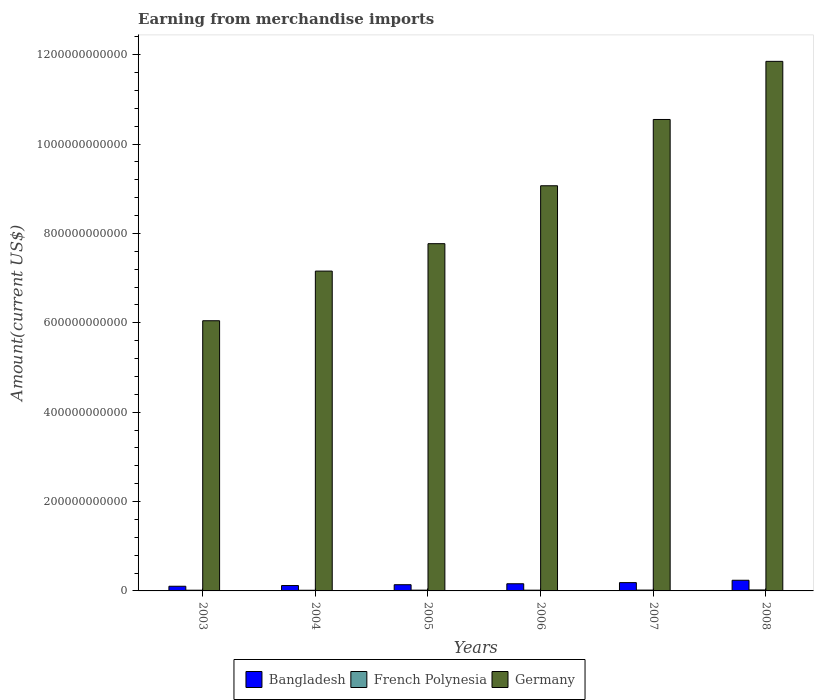How many bars are there on the 6th tick from the left?
Give a very brief answer. 3. What is the amount earned from merchandise imports in Bangladesh in 2006?
Offer a very short reply. 1.60e+1. Across all years, what is the maximum amount earned from merchandise imports in French Polynesia?
Ensure brevity in your answer.  2.17e+09. Across all years, what is the minimum amount earned from merchandise imports in Germany?
Provide a short and direct response. 6.05e+11. In which year was the amount earned from merchandise imports in Bangladesh maximum?
Ensure brevity in your answer.  2008. What is the total amount earned from merchandise imports in French Polynesia in the graph?
Make the answer very short. 1.05e+1. What is the difference between the amount earned from merchandise imports in Germany in 2005 and that in 2006?
Your response must be concise. -1.30e+11. What is the difference between the amount earned from merchandise imports in French Polynesia in 2007 and the amount earned from merchandise imports in Germany in 2005?
Offer a terse response. -7.75e+11. What is the average amount earned from merchandise imports in French Polynesia per year?
Offer a terse response. 1.75e+09. In the year 2005, what is the difference between the amount earned from merchandise imports in Bangladesh and amount earned from merchandise imports in French Polynesia?
Give a very brief answer. 1.22e+1. In how many years, is the amount earned from merchandise imports in French Polynesia greater than 480000000000 US$?
Ensure brevity in your answer.  0. What is the ratio of the amount earned from merchandise imports in French Polynesia in 2006 to that in 2008?
Offer a terse response. 0.76. Is the difference between the amount earned from merchandise imports in Bangladesh in 2005 and 2007 greater than the difference between the amount earned from merchandise imports in French Polynesia in 2005 and 2007?
Provide a short and direct response. No. What is the difference between the highest and the second highest amount earned from merchandise imports in Bangladesh?
Ensure brevity in your answer.  5.26e+09. What is the difference between the highest and the lowest amount earned from merchandise imports in French Polynesia?
Your response must be concise. 6.69e+08. In how many years, is the amount earned from merchandise imports in Bangladesh greater than the average amount earned from merchandise imports in Bangladesh taken over all years?
Offer a terse response. 3. How many bars are there?
Provide a succinct answer. 18. Are all the bars in the graph horizontal?
Your response must be concise. No. How many years are there in the graph?
Provide a short and direct response. 6. What is the difference between two consecutive major ticks on the Y-axis?
Your answer should be very brief. 2.00e+11. Does the graph contain any zero values?
Keep it short and to the point. No. Where does the legend appear in the graph?
Your response must be concise. Bottom center. How many legend labels are there?
Give a very brief answer. 3. How are the legend labels stacked?
Keep it short and to the point. Horizontal. What is the title of the graph?
Your answer should be very brief. Earning from merchandise imports. What is the label or title of the Y-axis?
Your answer should be compact. Amount(current US$). What is the Amount(current US$) of Bangladesh in 2003?
Provide a succinct answer. 1.04e+1. What is the Amount(current US$) of French Polynesia in 2003?
Provide a short and direct response. 1.58e+09. What is the Amount(current US$) in Germany in 2003?
Make the answer very short. 6.05e+11. What is the Amount(current US$) of Bangladesh in 2004?
Offer a very short reply. 1.20e+1. What is the Amount(current US$) in French Polynesia in 2004?
Your answer should be compact. 1.50e+09. What is the Amount(current US$) in Germany in 2004?
Give a very brief answer. 7.16e+11. What is the Amount(current US$) in Bangladesh in 2005?
Your answer should be compact. 1.39e+1. What is the Amount(current US$) of French Polynesia in 2005?
Your response must be concise. 1.72e+09. What is the Amount(current US$) in Germany in 2005?
Your answer should be very brief. 7.77e+11. What is the Amount(current US$) in Bangladesh in 2006?
Provide a succinct answer. 1.60e+1. What is the Amount(current US$) in French Polynesia in 2006?
Your response must be concise. 1.66e+09. What is the Amount(current US$) of Germany in 2006?
Keep it short and to the point. 9.07e+11. What is the Amount(current US$) of Bangladesh in 2007?
Your answer should be compact. 1.86e+1. What is the Amount(current US$) in French Polynesia in 2007?
Your answer should be compact. 1.86e+09. What is the Amount(current US$) of Germany in 2007?
Provide a short and direct response. 1.05e+12. What is the Amount(current US$) in Bangladesh in 2008?
Your answer should be very brief. 2.39e+1. What is the Amount(current US$) in French Polynesia in 2008?
Give a very brief answer. 2.17e+09. What is the Amount(current US$) of Germany in 2008?
Make the answer very short. 1.19e+12. Across all years, what is the maximum Amount(current US$) in Bangladesh?
Keep it short and to the point. 2.39e+1. Across all years, what is the maximum Amount(current US$) in French Polynesia?
Your answer should be compact. 2.17e+09. Across all years, what is the maximum Amount(current US$) in Germany?
Provide a succinct answer. 1.19e+12. Across all years, what is the minimum Amount(current US$) in Bangladesh?
Give a very brief answer. 1.04e+1. Across all years, what is the minimum Amount(current US$) of French Polynesia?
Make the answer very short. 1.50e+09. Across all years, what is the minimum Amount(current US$) in Germany?
Offer a terse response. 6.05e+11. What is the total Amount(current US$) of Bangladesh in the graph?
Provide a short and direct response. 9.48e+1. What is the total Amount(current US$) in French Polynesia in the graph?
Offer a terse response. 1.05e+1. What is the total Amount(current US$) in Germany in the graph?
Your response must be concise. 5.24e+12. What is the difference between the Amount(current US$) in Bangladesh in 2003 and that in 2004?
Ensure brevity in your answer.  -1.60e+09. What is the difference between the Amount(current US$) in French Polynesia in 2003 and that in 2004?
Offer a terse response. 8.51e+07. What is the difference between the Amount(current US$) of Germany in 2003 and that in 2004?
Make the answer very short. -1.11e+11. What is the difference between the Amount(current US$) of Bangladesh in 2003 and that in 2005?
Keep it short and to the point. -3.46e+09. What is the difference between the Amount(current US$) in French Polynesia in 2003 and that in 2005?
Give a very brief answer. -1.38e+08. What is the difference between the Amount(current US$) in Germany in 2003 and that in 2005?
Offer a terse response. -1.72e+11. What is the difference between the Amount(current US$) of Bangladesh in 2003 and that in 2006?
Your answer should be compact. -5.60e+09. What is the difference between the Amount(current US$) of French Polynesia in 2003 and that in 2006?
Your answer should be very brief. -7.06e+07. What is the difference between the Amount(current US$) of Germany in 2003 and that in 2006?
Provide a succinct answer. -3.02e+11. What is the difference between the Amount(current US$) in Bangladesh in 2003 and that in 2007?
Offer a terse response. -8.16e+09. What is the difference between the Amount(current US$) of French Polynesia in 2003 and that in 2007?
Your response must be concise. -2.78e+08. What is the difference between the Amount(current US$) in Germany in 2003 and that in 2007?
Provide a succinct answer. -4.50e+11. What is the difference between the Amount(current US$) in Bangladesh in 2003 and that in 2008?
Provide a succinct answer. -1.34e+1. What is the difference between the Amount(current US$) in French Polynesia in 2003 and that in 2008?
Ensure brevity in your answer.  -5.84e+08. What is the difference between the Amount(current US$) in Germany in 2003 and that in 2008?
Your response must be concise. -5.80e+11. What is the difference between the Amount(current US$) of Bangladesh in 2004 and that in 2005?
Offer a very short reply. -1.85e+09. What is the difference between the Amount(current US$) of French Polynesia in 2004 and that in 2005?
Ensure brevity in your answer.  -2.23e+08. What is the difference between the Amount(current US$) of Germany in 2004 and that in 2005?
Provide a succinct answer. -6.13e+1. What is the difference between the Amount(current US$) of Bangladesh in 2004 and that in 2006?
Your answer should be very brief. -4.00e+09. What is the difference between the Amount(current US$) in French Polynesia in 2004 and that in 2006?
Ensure brevity in your answer.  -1.56e+08. What is the difference between the Amount(current US$) of Germany in 2004 and that in 2006?
Make the answer very short. -1.91e+11. What is the difference between the Amount(current US$) of Bangladesh in 2004 and that in 2007?
Make the answer very short. -6.56e+09. What is the difference between the Amount(current US$) in French Polynesia in 2004 and that in 2007?
Your answer should be compact. -3.63e+08. What is the difference between the Amount(current US$) of Germany in 2004 and that in 2007?
Provide a succinct answer. -3.39e+11. What is the difference between the Amount(current US$) in Bangladesh in 2004 and that in 2008?
Keep it short and to the point. -1.18e+1. What is the difference between the Amount(current US$) in French Polynesia in 2004 and that in 2008?
Your response must be concise. -6.69e+08. What is the difference between the Amount(current US$) in Germany in 2004 and that in 2008?
Provide a short and direct response. -4.69e+11. What is the difference between the Amount(current US$) of Bangladesh in 2005 and that in 2006?
Provide a succinct answer. -2.14e+09. What is the difference between the Amount(current US$) in French Polynesia in 2005 and that in 2006?
Keep it short and to the point. 6.76e+07. What is the difference between the Amount(current US$) of Germany in 2005 and that in 2006?
Provide a succinct answer. -1.30e+11. What is the difference between the Amount(current US$) of Bangladesh in 2005 and that in 2007?
Provide a short and direct response. -4.71e+09. What is the difference between the Amount(current US$) in French Polynesia in 2005 and that in 2007?
Ensure brevity in your answer.  -1.40e+08. What is the difference between the Amount(current US$) of Germany in 2005 and that in 2007?
Make the answer very short. -2.78e+11. What is the difference between the Amount(current US$) of Bangladesh in 2005 and that in 2008?
Offer a very short reply. -9.97e+09. What is the difference between the Amount(current US$) in French Polynesia in 2005 and that in 2008?
Give a very brief answer. -4.45e+08. What is the difference between the Amount(current US$) of Germany in 2005 and that in 2008?
Offer a very short reply. -4.08e+11. What is the difference between the Amount(current US$) of Bangladesh in 2006 and that in 2007?
Your answer should be compact. -2.56e+09. What is the difference between the Amount(current US$) of French Polynesia in 2006 and that in 2007?
Offer a terse response. -2.08e+08. What is the difference between the Amount(current US$) of Germany in 2006 and that in 2007?
Offer a terse response. -1.48e+11. What is the difference between the Amount(current US$) in Bangladesh in 2006 and that in 2008?
Your answer should be very brief. -7.83e+09. What is the difference between the Amount(current US$) in French Polynesia in 2006 and that in 2008?
Your answer should be very brief. -5.13e+08. What is the difference between the Amount(current US$) in Germany in 2006 and that in 2008?
Provide a short and direct response. -2.78e+11. What is the difference between the Amount(current US$) of Bangladesh in 2007 and that in 2008?
Provide a succinct answer. -5.26e+09. What is the difference between the Amount(current US$) of French Polynesia in 2007 and that in 2008?
Give a very brief answer. -3.06e+08. What is the difference between the Amount(current US$) in Germany in 2007 and that in 2008?
Your response must be concise. -1.30e+11. What is the difference between the Amount(current US$) in Bangladesh in 2003 and the Amount(current US$) in French Polynesia in 2004?
Make the answer very short. 8.93e+09. What is the difference between the Amount(current US$) of Bangladesh in 2003 and the Amount(current US$) of Germany in 2004?
Provide a succinct answer. -7.05e+11. What is the difference between the Amount(current US$) in French Polynesia in 2003 and the Amount(current US$) in Germany in 2004?
Offer a terse response. -7.14e+11. What is the difference between the Amount(current US$) of Bangladesh in 2003 and the Amount(current US$) of French Polynesia in 2005?
Offer a terse response. 8.71e+09. What is the difference between the Amount(current US$) in Bangladesh in 2003 and the Amount(current US$) in Germany in 2005?
Offer a very short reply. -7.67e+11. What is the difference between the Amount(current US$) in French Polynesia in 2003 and the Amount(current US$) in Germany in 2005?
Your response must be concise. -7.75e+11. What is the difference between the Amount(current US$) in Bangladesh in 2003 and the Amount(current US$) in French Polynesia in 2006?
Provide a succinct answer. 8.78e+09. What is the difference between the Amount(current US$) of Bangladesh in 2003 and the Amount(current US$) of Germany in 2006?
Ensure brevity in your answer.  -8.96e+11. What is the difference between the Amount(current US$) in French Polynesia in 2003 and the Amount(current US$) in Germany in 2006?
Ensure brevity in your answer.  -9.05e+11. What is the difference between the Amount(current US$) in Bangladesh in 2003 and the Amount(current US$) in French Polynesia in 2007?
Your answer should be very brief. 8.57e+09. What is the difference between the Amount(current US$) of Bangladesh in 2003 and the Amount(current US$) of Germany in 2007?
Provide a short and direct response. -1.04e+12. What is the difference between the Amount(current US$) in French Polynesia in 2003 and the Amount(current US$) in Germany in 2007?
Provide a succinct answer. -1.05e+12. What is the difference between the Amount(current US$) in Bangladesh in 2003 and the Amount(current US$) in French Polynesia in 2008?
Make the answer very short. 8.27e+09. What is the difference between the Amount(current US$) in Bangladesh in 2003 and the Amount(current US$) in Germany in 2008?
Provide a succinct answer. -1.17e+12. What is the difference between the Amount(current US$) in French Polynesia in 2003 and the Amount(current US$) in Germany in 2008?
Ensure brevity in your answer.  -1.18e+12. What is the difference between the Amount(current US$) of Bangladesh in 2004 and the Amount(current US$) of French Polynesia in 2005?
Give a very brief answer. 1.03e+1. What is the difference between the Amount(current US$) of Bangladesh in 2004 and the Amount(current US$) of Germany in 2005?
Give a very brief answer. -7.65e+11. What is the difference between the Amount(current US$) in French Polynesia in 2004 and the Amount(current US$) in Germany in 2005?
Offer a very short reply. -7.76e+11. What is the difference between the Amount(current US$) of Bangladesh in 2004 and the Amount(current US$) of French Polynesia in 2006?
Give a very brief answer. 1.04e+1. What is the difference between the Amount(current US$) in Bangladesh in 2004 and the Amount(current US$) in Germany in 2006?
Ensure brevity in your answer.  -8.95e+11. What is the difference between the Amount(current US$) in French Polynesia in 2004 and the Amount(current US$) in Germany in 2006?
Make the answer very short. -9.05e+11. What is the difference between the Amount(current US$) in Bangladesh in 2004 and the Amount(current US$) in French Polynesia in 2007?
Your response must be concise. 1.02e+1. What is the difference between the Amount(current US$) in Bangladesh in 2004 and the Amount(current US$) in Germany in 2007?
Offer a terse response. -1.04e+12. What is the difference between the Amount(current US$) of French Polynesia in 2004 and the Amount(current US$) of Germany in 2007?
Ensure brevity in your answer.  -1.05e+12. What is the difference between the Amount(current US$) in Bangladesh in 2004 and the Amount(current US$) in French Polynesia in 2008?
Provide a short and direct response. 9.87e+09. What is the difference between the Amount(current US$) of Bangladesh in 2004 and the Amount(current US$) of Germany in 2008?
Your answer should be very brief. -1.17e+12. What is the difference between the Amount(current US$) of French Polynesia in 2004 and the Amount(current US$) of Germany in 2008?
Make the answer very short. -1.18e+12. What is the difference between the Amount(current US$) of Bangladesh in 2005 and the Amount(current US$) of French Polynesia in 2006?
Make the answer very short. 1.22e+1. What is the difference between the Amount(current US$) of Bangladesh in 2005 and the Amount(current US$) of Germany in 2006?
Provide a succinct answer. -8.93e+11. What is the difference between the Amount(current US$) in French Polynesia in 2005 and the Amount(current US$) in Germany in 2006?
Keep it short and to the point. -9.05e+11. What is the difference between the Amount(current US$) of Bangladesh in 2005 and the Amount(current US$) of French Polynesia in 2007?
Provide a succinct answer. 1.20e+1. What is the difference between the Amount(current US$) in Bangladesh in 2005 and the Amount(current US$) in Germany in 2007?
Make the answer very short. -1.04e+12. What is the difference between the Amount(current US$) in French Polynesia in 2005 and the Amount(current US$) in Germany in 2007?
Your answer should be very brief. -1.05e+12. What is the difference between the Amount(current US$) in Bangladesh in 2005 and the Amount(current US$) in French Polynesia in 2008?
Your response must be concise. 1.17e+1. What is the difference between the Amount(current US$) of Bangladesh in 2005 and the Amount(current US$) of Germany in 2008?
Make the answer very short. -1.17e+12. What is the difference between the Amount(current US$) in French Polynesia in 2005 and the Amount(current US$) in Germany in 2008?
Offer a terse response. -1.18e+12. What is the difference between the Amount(current US$) in Bangladesh in 2006 and the Amount(current US$) in French Polynesia in 2007?
Ensure brevity in your answer.  1.42e+1. What is the difference between the Amount(current US$) in Bangladesh in 2006 and the Amount(current US$) in Germany in 2007?
Offer a terse response. -1.04e+12. What is the difference between the Amount(current US$) of French Polynesia in 2006 and the Amount(current US$) of Germany in 2007?
Provide a succinct answer. -1.05e+12. What is the difference between the Amount(current US$) in Bangladesh in 2006 and the Amount(current US$) in French Polynesia in 2008?
Make the answer very short. 1.39e+1. What is the difference between the Amount(current US$) of Bangladesh in 2006 and the Amount(current US$) of Germany in 2008?
Provide a short and direct response. -1.17e+12. What is the difference between the Amount(current US$) of French Polynesia in 2006 and the Amount(current US$) of Germany in 2008?
Offer a terse response. -1.18e+12. What is the difference between the Amount(current US$) of Bangladesh in 2007 and the Amount(current US$) of French Polynesia in 2008?
Give a very brief answer. 1.64e+1. What is the difference between the Amount(current US$) of Bangladesh in 2007 and the Amount(current US$) of Germany in 2008?
Give a very brief answer. -1.17e+12. What is the difference between the Amount(current US$) of French Polynesia in 2007 and the Amount(current US$) of Germany in 2008?
Make the answer very short. -1.18e+12. What is the average Amount(current US$) of Bangladesh per year?
Your answer should be compact. 1.58e+1. What is the average Amount(current US$) in French Polynesia per year?
Offer a terse response. 1.75e+09. What is the average Amount(current US$) of Germany per year?
Your answer should be compact. 8.74e+11. In the year 2003, what is the difference between the Amount(current US$) of Bangladesh and Amount(current US$) of French Polynesia?
Offer a terse response. 8.85e+09. In the year 2003, what is the difference between the Amount(current US$) in Bangladesh and Amount(current US$) in Germany?
Your response must be concise. -5.94e+11. In the year 2003, what is the difference between the Amount(current US$) in French Polynesia and Amount(current US$) in Germany?
Give a very brief answer. -6.03e+11. In the year 2004, what is the difference between the Amount(current US$) in Bangladesh and Amount(current US$) in French Polynesia?
Your answer should be compact. 1.05e+1. In the year 2004, what is the difference between the Amount(current US$) of Bangladesh and Amount(current US$) of Germany?
Provide a succinct answer. -7.04e+11. In the year 2004, what is the difference between the Amount(current US$) of French Polynesia and Amount(current US$) of Germany?
Offer a terse response. -7.14e+11. In the year 2005, what is the difference between the Amount(current US$) in Bangladesh and Amount(current US$) in French Polynesia?
Offer a very short reply. 1.22e+1. In the year 2005, what is the difference between the Amount(current US$) of Bangladesh and Amount(current US$) of Germany?
Your response must be concise. -7.63e+11. In the year 2005, what is the difference between the Amount(current US$) in French Polynesia and Amount(current US$) in Germany?
Offer a very short reply. -7.75e+11. In the year 2006, what is the difference between the Amount(current US$) of Bangladesh and Amount(current US$) of French Polynesia?
Your answer should be very brief. 1.44e+1. In the year 2006, what is the difference between the Amount(current US$) of Bangladesh and Amount(current US$) of Germany?
Keep it short and to the point. -8.91e+11. In the year 2006, what is the difference between the Amount(current US$) in French Polynesia and Amount(current US$) in Germany?
Offer a terse response. -9.05e+11. In the year 2007, what is the difference between the Amount(current US$) of Bangladesh and Amount(current US$) of French Polynesia?
Give a very brief answer. 1.67e+1. In the year 2007, what is the difference between the Amount(current US$) of Bangladesh and Amount(current US$) of Germany?
Offer a terse response. -1.04e+12. In the year 2007, what is the difference between the Amount(current US$) in French Polynesia and Amount(current US$) in Germany?
Give a very brief answer. -1.05e+12. In the year 2008, what is the difference between the Amount(current US$) in Bangladesh and Amount(current US$) in French Polynesia?
Provide a succinct answer. 2.17e+1. In the year 2008, what is the difference between the Amount(current US$) of Bangladesh and Amount(current US$) of Germany?
Keep it short and to the point. -1.16e+12. In the year 2008, what is the difference between the Amount(current US$) in French Polynesia and Amount(current US$) in Germany?
Make the answer very short. -1.18e+12. What is the ratio of the Amount(current US$) in Bangladesh in 2003 to that in 2004?
Your response must be concise. 0.87. What is the ratio of the Amount(current US$) in French Polynesia in 2003 to that in 2004?
Make the answer very short. 1.06. What is the ratio of the Amount(current US$) in Germany in 2003 to that in 2004?
Offer a terse response. 0.84. What is the ratio of the Amount(current US$) in Bangladesh in 2003 to that in 2005?
Your response must be concise. 0.75. What is the ratio of the Amount(current US$) of French Polynesia in 2003 to that in 2005?
Provide a short and direct response. 0.92. What is the ratio of the Amount(current US$) in Germany in 2003 to that in 2005?
Give a very brief answer. 0.78. What is the ratio of the Amount(current US$) in Bangladesh in 2003 to that in 2006?
Provide a short and direct response. 0.65. What is the ratio of the Amount(current US$) in French Polynesia in 2003 to that in 2006?
Offer a very short reply. 0.96. What is the ratio of the Amount(current US$) of Germany in 2003 to that in 2006?
Provide a short and direct response. 0.67. What is the ratio of the Amount(current US$) in Bangladesh in 2003 to that in 2007?
Provide a succinct answer. 0.56. What is the ratio of the Amount(current US$) in French Polynesia in 2003 to that in 2007?
Make the answer very short. 0.85. What is the ratio of the Amount(current US$) in Germany in 2003 to that in 2007?
Give a very brief answer. 0.57. What is the ratio of the Amount(current US$) of Bangladesh in 2003 to that in 2008?
Offer a very short reply. 0.44. What is the ratio of the Amount(current US$) in French Polynesia in 2003 to that in 2008?
Make the answer very short. 0.73. What is the ratio of the Amount(current US$) in Germany in 2003 to that in 2008?
Provide a succinct answer. 0.51. What is the ratio of the Amount(current US$) of Bangladesh in 2004 to that in 2005?
Your answer should be compact. 0.87. What is the ratio of the Amount(current US$) of French Polynesia in 2004 to that in 2005?
Provide a short and direct response. 0.87. What is the ratio of the Amount(current US$) in Germany in 2004 to that in 2005?
Provide a short and direct response. 0.92. What is the ratio of the Amount(current US$) of Bangladesh in 2004 to that in 2006?
Keep it short and to the point. 0.75. What is the ratio of the Amount(current US$) in French Polynesia in 2004 to that in 2006?
Ensure brevity in your answer.  0.91. What is the ratio of the Amount(current US$) in Germany in 2004 to that in 2006?
Your answer should be compact. 0.79. What is the ratio of the Amount(current US$) of Bangladesh in 2004 to that in 2007?
Offer a very short reply. 0.65. What is the ratio of the Amount(current US$) of French Polynesia in 2004 to that in 2007?
Give a very brief answer. 0.81. What is the ratio of the Amount(current US$) in Germany in 2004 to that in 2007?
Keep it short and to the point. 0.68. What is the ratio of the Amount(current US$) in Bangladesh in 2004 to that in 2008?
Your answer should be very brief. 0.5. What is the ratio of the Amount(current US$) of French Polynesia in 2004 to that in 2008?
Give a very brief answer. 0.69. What is the ratio of the Amount(current US$) in Germany in 2004 to that in 2008?
Keep it short and to the point. 0.6. What is the ratio of the Amount(current US$) in Bangladesh in 2005 to that in 2006?
Your answer should be very brief. 0.87. What is the ratio of the Amount(current US$) of French Polynesia in 2005 to that in 2006?
Offer a very short reply. 1.04. What is the ratio of the Amount(current US$) in Germany in 2005 to that in 2006?
Your response must be concise. 0.86. What is the ratio of the Amount(current US$) of Bangladesh in 2005 to that in 2007?
Give a very brief answer. 0.75. What is the ratio of the Amount(current US$) in French Polynesia in 2005 to that in 2007?
Provide a short and direct response. 0.92. What is the ratio of the Amount(current US$) in Germany in 2005 to that in 2007?
Give a very brief answer. 0.74. What is the ratio of the Amount(current US$) of Bangladesh in 2005 to that in 2008?
Ensure brevity in your answer.  0.58. What is the ratio of the Amount(current US$) in French Polynesia in 2005 to that in 2008?
Offer a terse response. 0.79. What is the ratio of the Amount(current US$) of Germany in 2005 to that in 2008?
Your response must be concise. 0.66. What is the ratio of the Amount(current US$) in Bangladesh in 2006 to that in 2007?
Your answer should be very brief. 0.86. What is the ratio of the Amount(current US$) in French Polynesia in 2006 to that in 2007?
Offer a very short reply. 0.89. What is the ratio of the Amount(current US$) in Germany in 2006 to that in 2007?
Your answer should be compact. 0.86. What is the ratio of the Amount(current US$) in Bangladesh in 2006 to that in 2008?
Provide a short and direct response. 0.67. What is the ratio of the Amount(current US$) in French Polynesia in 2006 to that in 2008?
Give a very brief answer. 0.76. What is the ratio of the Amount(current US$) of Germany in 2006 to that in 2008?
Your answer should be compact. 0.77. What is the ratio of the Amount(current US$) in Bangladesh in 2007 to that in 2008?
Provide a succinct answer. 0.78. What is the ratio of the Amount(current US$) of French Polynesia in 2007 to that in 2008?
Offer a terse response. 0.86. What is the ratio of the Amount(current US$) in Germany in 2007 to that in 2008?
Provide a succinct answer. 0.89. What is the difference between the highest and the second highest Amount(current US$) of Bangladesh?
Offer a very short reply. 5.26e+09. What is the difference between the highest and the second highest Amount(current US$) of French Polynesia?
Offer a very short reply. 3.06e+08. What is the difference between the highest and the second highest Amount(current US$) in Germany?
Provide a short and direct response. 1.30e+11. What is the difference between the highest and the lowest Amount(current US$) in Bangladesh?
Provide a succinct answer. 1.34e+1. What is the difference between the highest and the lowest Amount(current US$) of French Polynesia?
Ensure brevity in your answer.  6.69e+08. What is the difference between the highest and the lowest Amount(current US$) in Germany?
Ensure brevity in your answer.  5.80e+11. 